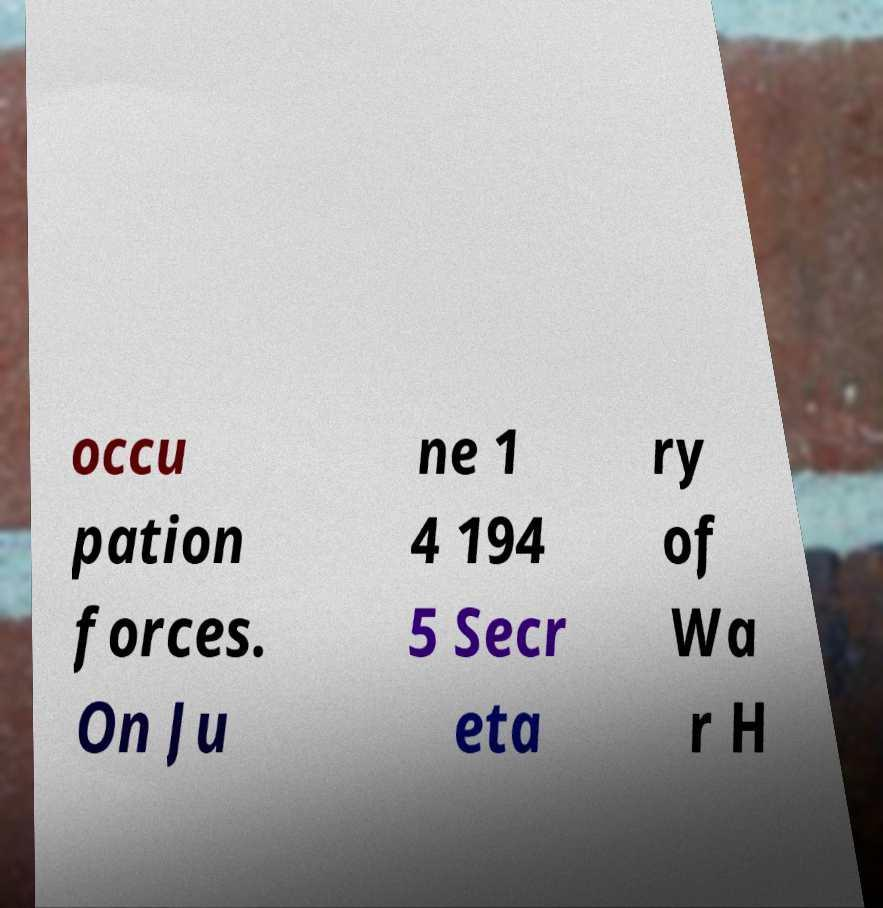Can you read and provide the text displayed in the image?This photo seems to have some interesting text. Can you extract and type it out for me? occu pation forces. On Ju ne 1 4 194 5 Secr eta ry of Wa r H 